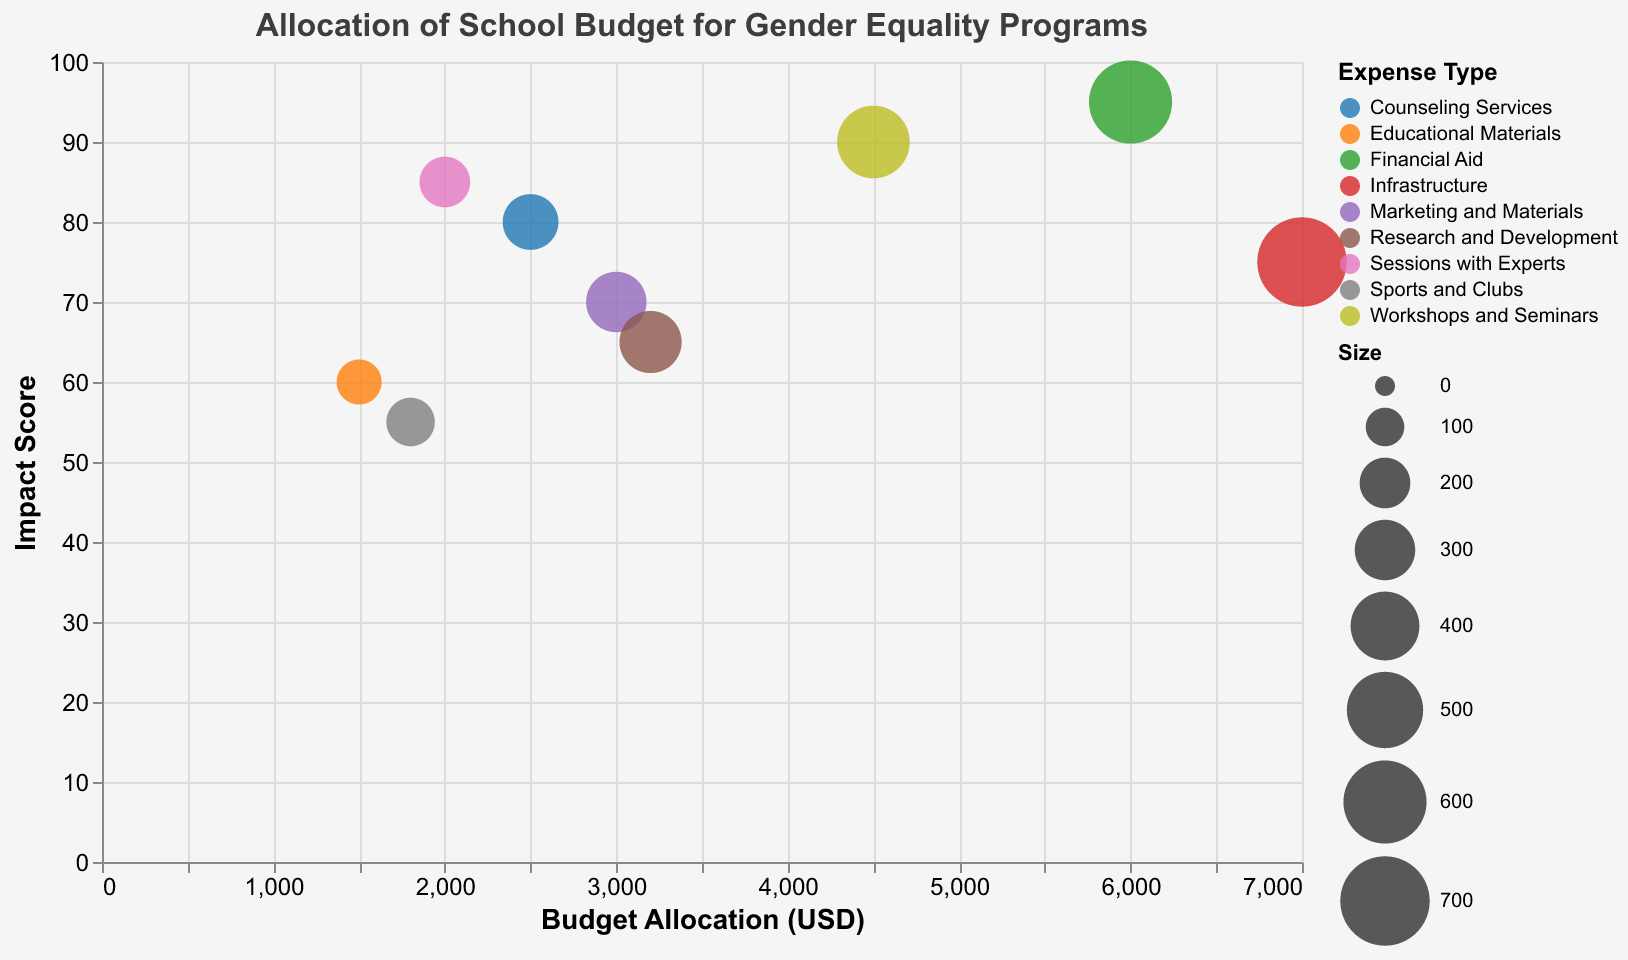How many gender equality programs are listed in the bubble chart? Count the number of distinct bubbles in the chart, each representing a different program.
Answer: 9 Which program has the highest budget allocation and what is that amount? Identify the bubble farthest to the right on the x-axis; the tooltip will show the "Program" and "Amount (USD)".
Answer: "Gender-Neutral Facilities", 7000 What is the impact score of the program with the lowest budget allocation? Find the bubble farthest to the left on the x-axis; the tooltip will show the "Impact (Score)".
Answer: 60 (Anti-Bullying Programs) Which program has the highest impact score, and what is the score? Identify the bubble highest on the y-axis; the tooltip will show the "Program" and "Impact (Score)".
Answer: "Scholarships and Grants", 95 What is the total budget allocation for programs with an impact score greater than 80? Sum the "Amount (USD)" for bubbles with "Impact (Score)" greater than 80 (Student Workshops: 2000, Teacher Training: 4500, Scholarships & Grants: 6000).
Answer: 12500 Which has a larger budget allocation: Student Workshops or Anti-Bullying Programs? Compare the x-coordinates of the bubbles for both programs; the tooltip will show the "Amount (USD)" for each.
Answer: Student Workshops (2000 vs 1500) Among Marketing and Materials and Sports and Clubs, which type of expense has a larger bubble size? Compare the size of the bubbles for "Marketing and Materials" and "Sports and Clubs".
Answer: Marketing and Materials (300 vs 180) What is the average impact score of the programs categorized under Workshops and Seminars and Sessions with Experts? Average the "Impact (Score)" for "Teacher Training" and "Student Workshops" (90 and 85).
Answer: 87.5 What is the difference in budget allocations between Gender-Neutral Facilities and Inclusive Curriculum Development? Calculate the difference between the "Amount (USD)" for both programs (7000 - 3200).
Answer: 3800 Which program represents Counseling Services, and what is its impact score and budget allocation? Find the bubble labeled "Counseling Services"; the tooltip will show the "Program", "Impact (Score)", and "Amount (USD)".
Answer: Mental Health Support, 80, 2500 